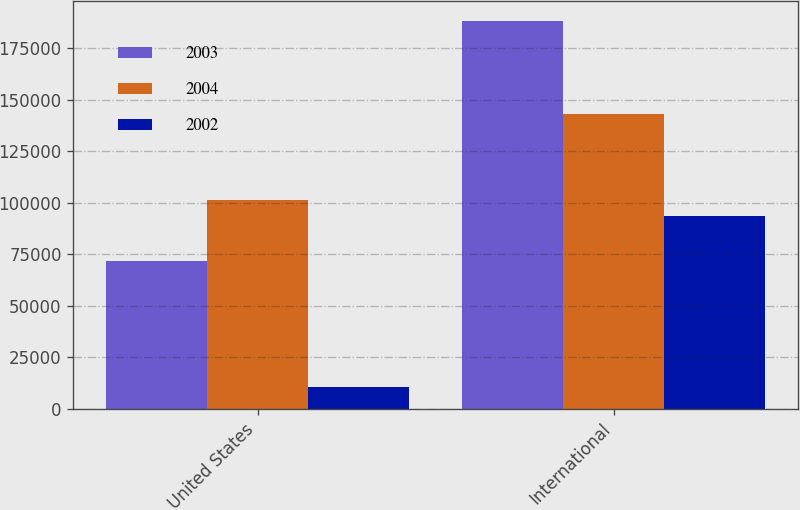<chart> <loc_0><loc_0><loc_500><loc_500><stacked_bar_chart><ecel><fcel>United States<fcel>International<nl><fcel>2003<fcel>71759<fcel>188329<nl><fcel>2004<fcel>101135<fcel>142929<nl><fcel>2002<fcel>10415<fcel>93673<nl></chart> 